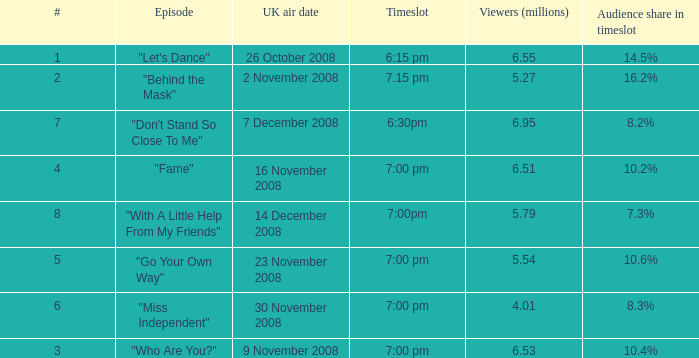Name the total number of timeslot for number 1 1.0. 